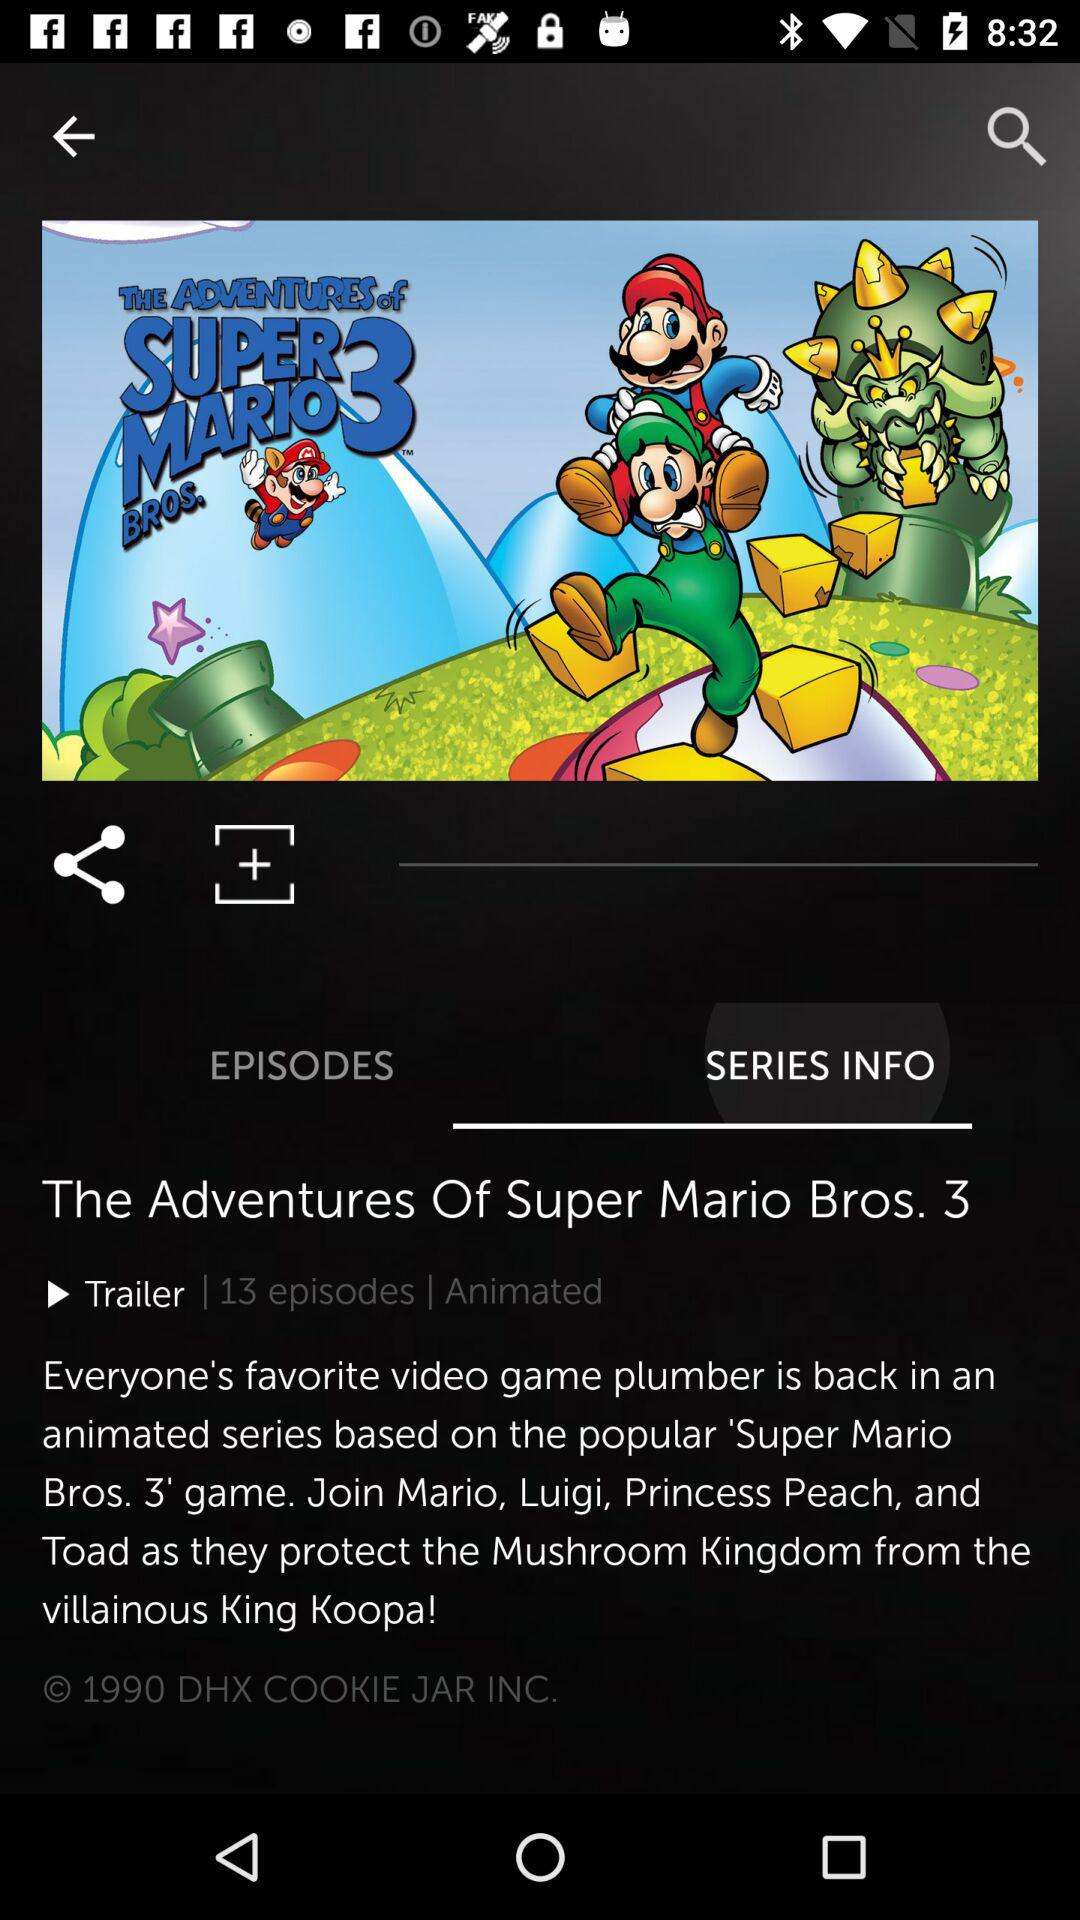Which tab am I on? You are on "SERIES INFO" tab. 